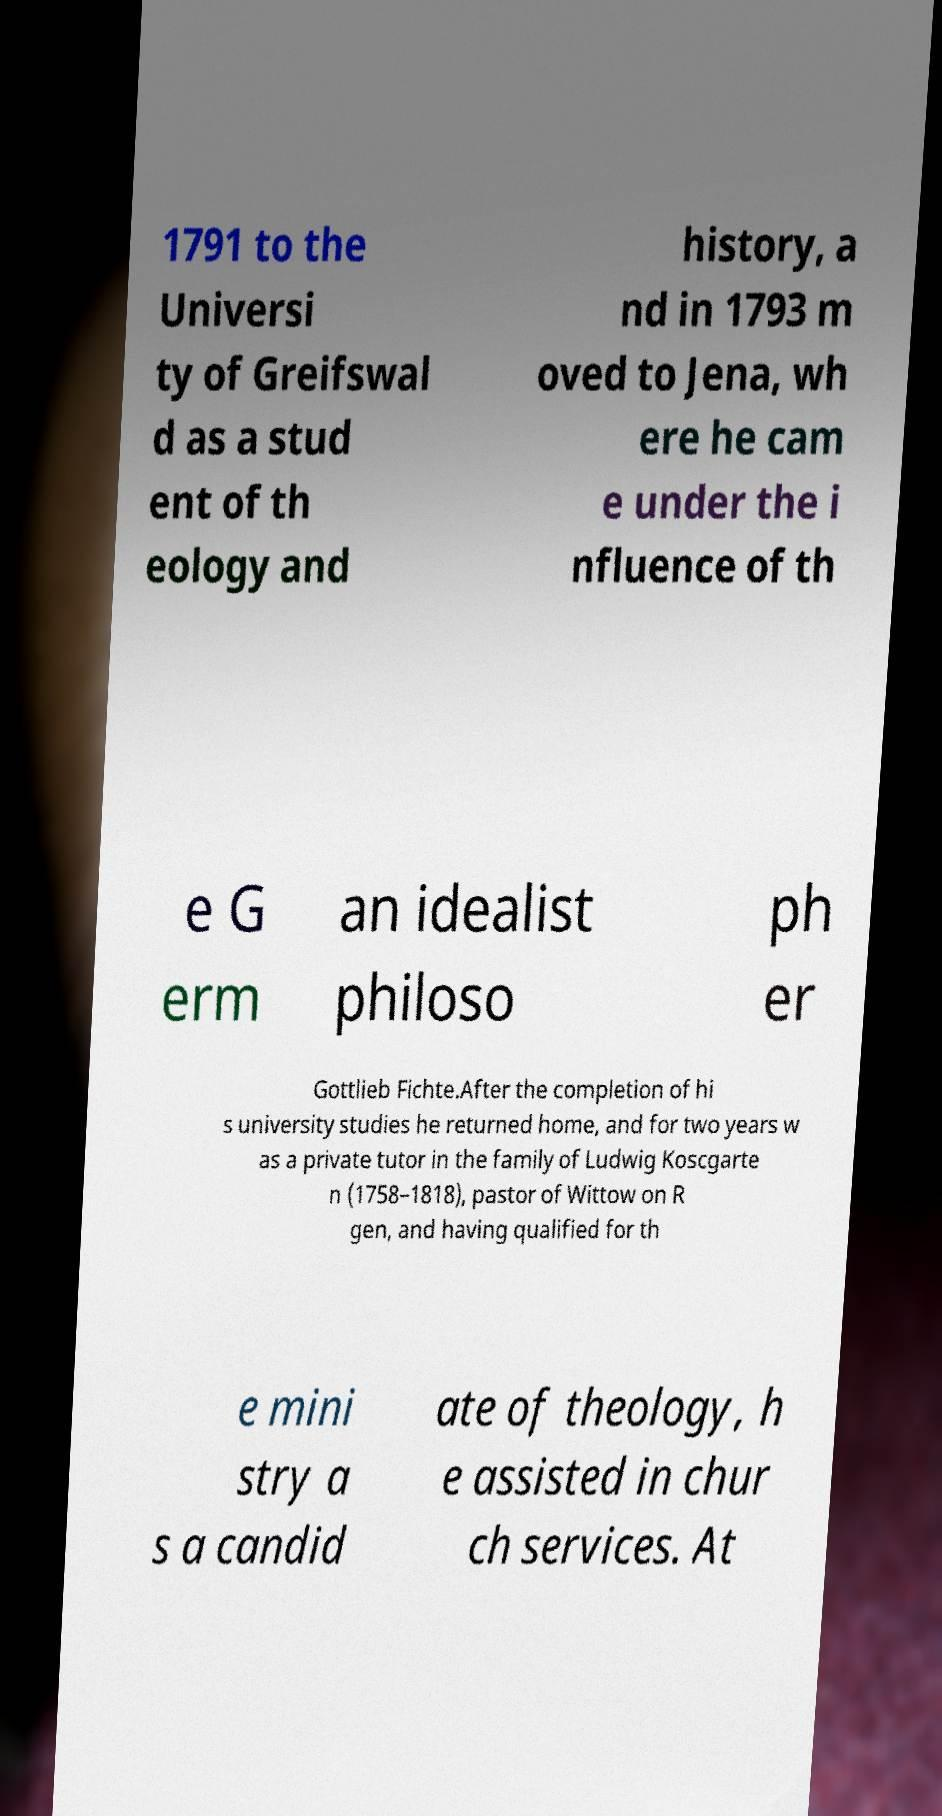Could you assist in decoding the text presented in this image and type it out clearly? 1791 to the Universi ty of Greifswal d as a stud ent of th eology and history, a nd in 1793 m oved to Jena, wh ere he cam e under the i nfluence of th e G erm an idealist philoso ph er Gottlieb Fichte.After the completion of hi s university studies he returned home, and for two years w as a private tutor in the family of Ludwig Koscgarte n (1758–1818), pastor of Wittow on R gen, and having qualified for th e mini stry a s a candid ate of theology, h e assisted in chur ch services. At 